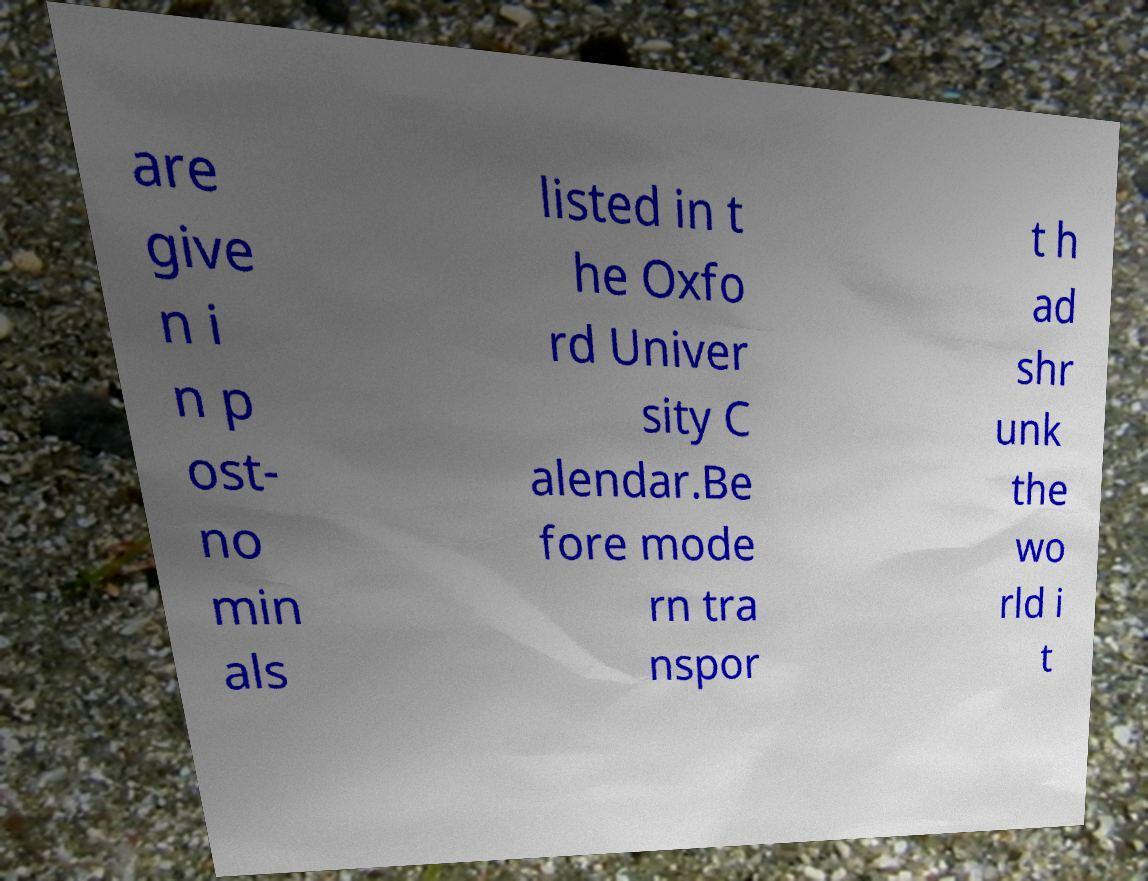Please identify and transcribe the text found in this image. are give n i n p ost- no min als listed in t he Oxfo rd Univer sity C alendar.Be fore mode rn tra nspor t h ad shr unk the wo rld i t 